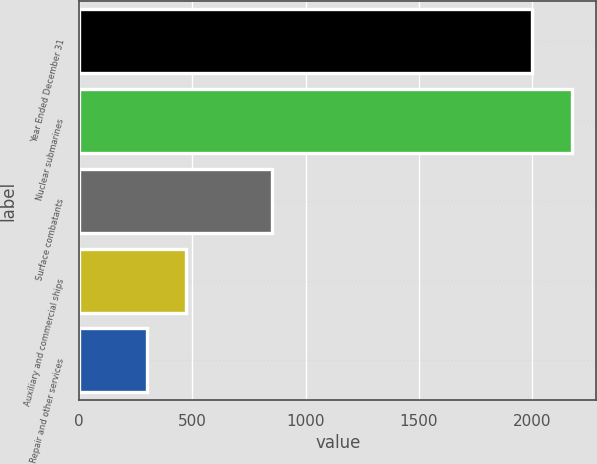<chart> <loc_0><loc_0><loc_500><loc_500><bar_chart><fcel>Year Ended December 31<fcel>Nuclear submarines<fcel>Surface combatants<fcel>Auxiliary and commercial ships<fcel>Repair and other services<nl><fcel>2002<fcel>2175.3<fcel>852<fcel>471<fcel>297<nl></chart> 